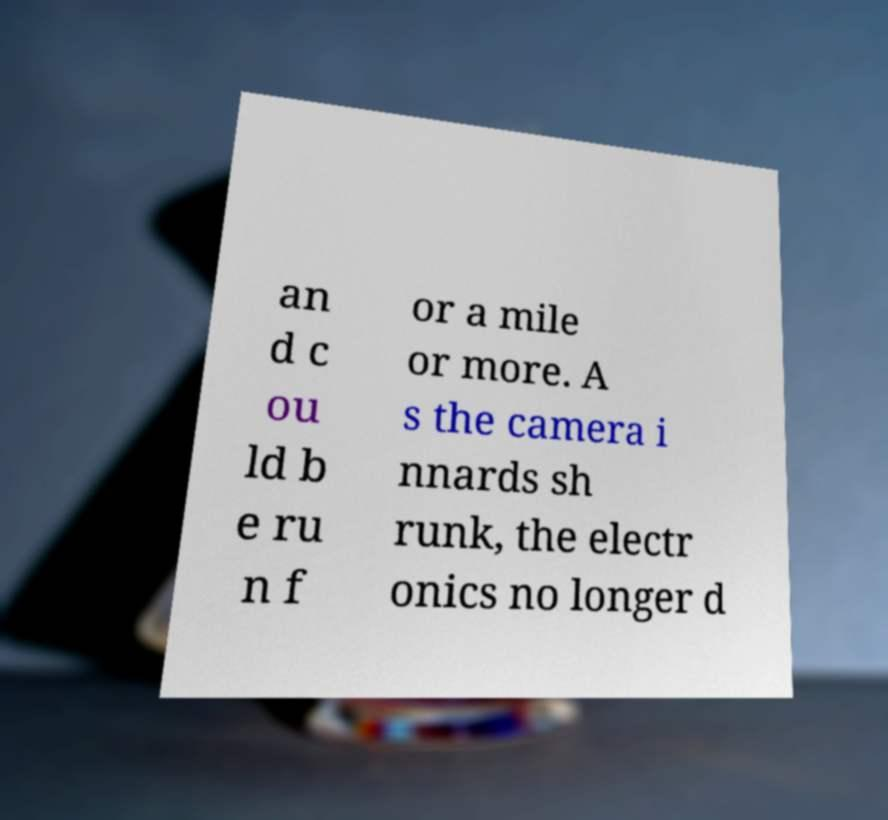Could you assist in decoding the text presented in this image and type it out clearly? an d c ou ld b e ru n f or a mile or more. A s the camera i nnards sh runk, the electr onics no longer d 